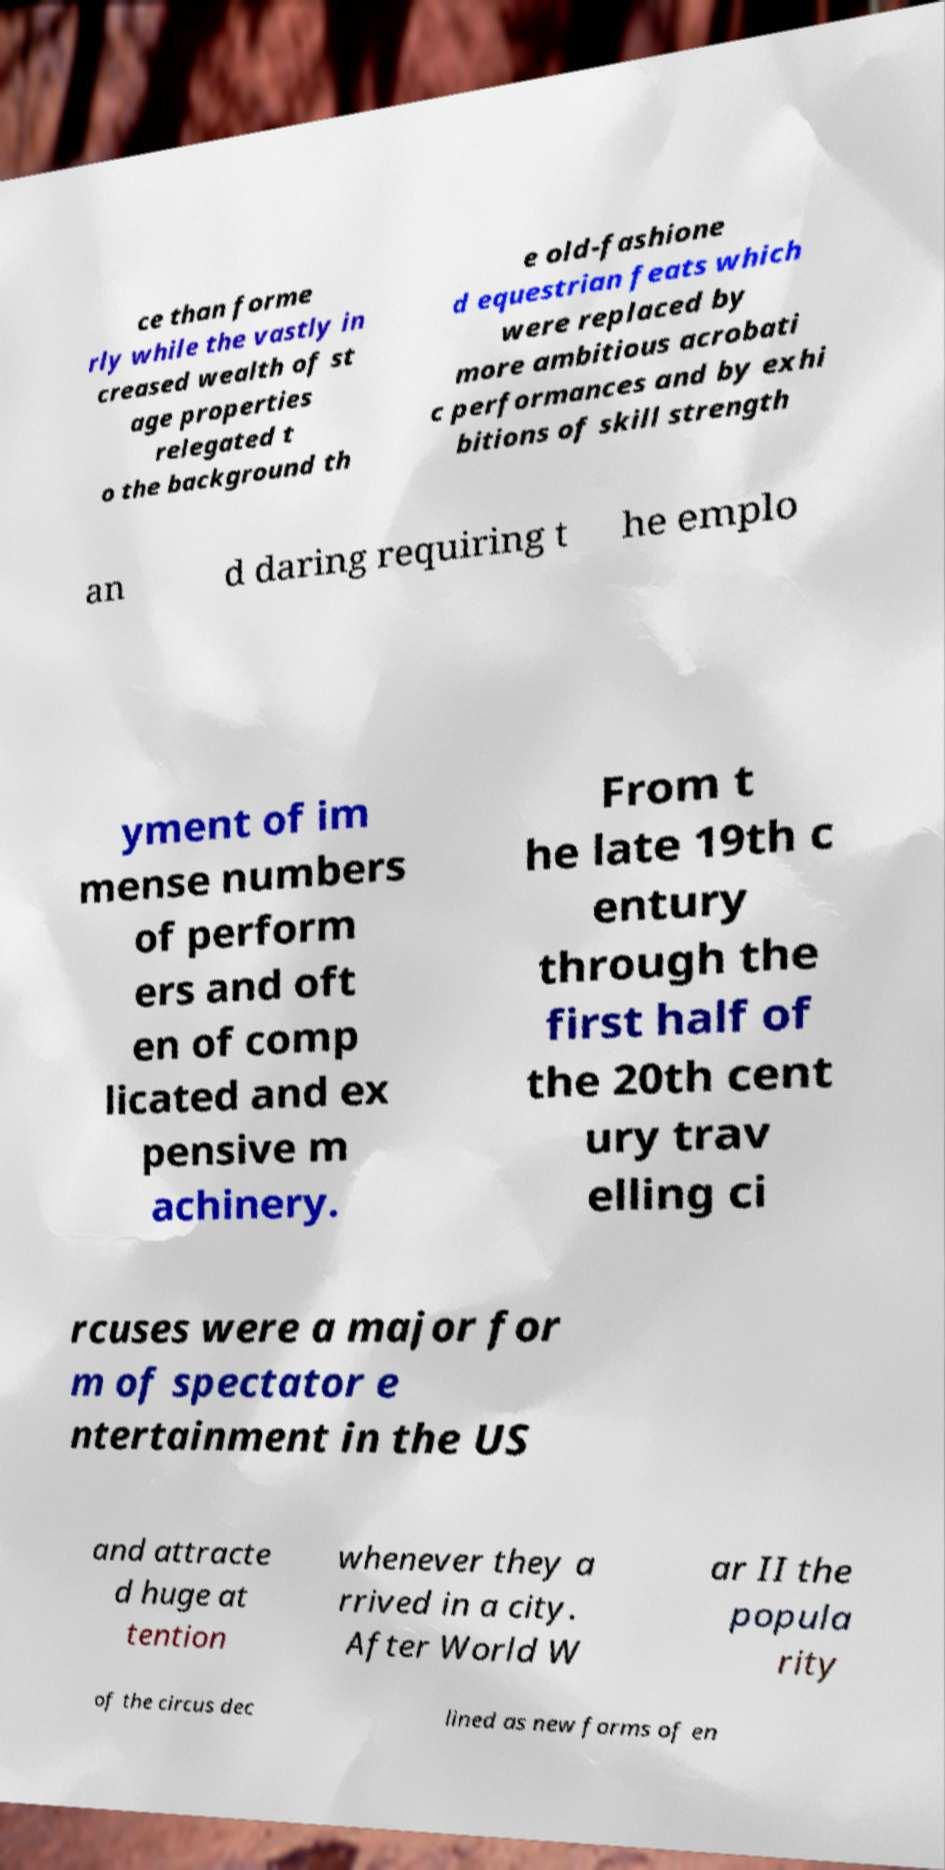What messages or text are displayed in this image? I need them in a readable, typed format. ce than forme rly while the vastly in creased wealth of st age properties relegated t o the background th e old-fashione d equestrian feats which were replaced by more ambitious acrobati c performances and by exhi bitions of skill strength an d daring requiring t he emplo yment of im mense numbers of perform ers and oft en of comp licated and ex pensive m achinery. From t he late 19th c entury through the first half of the 20th cent ury trav elling ci rcuses were a major for m of spectator e ntertainment in the US and attracte d huge at tention whenever they a rrived in a city. After World W ar II the popula rity of the circus dec lined as new forms of en 